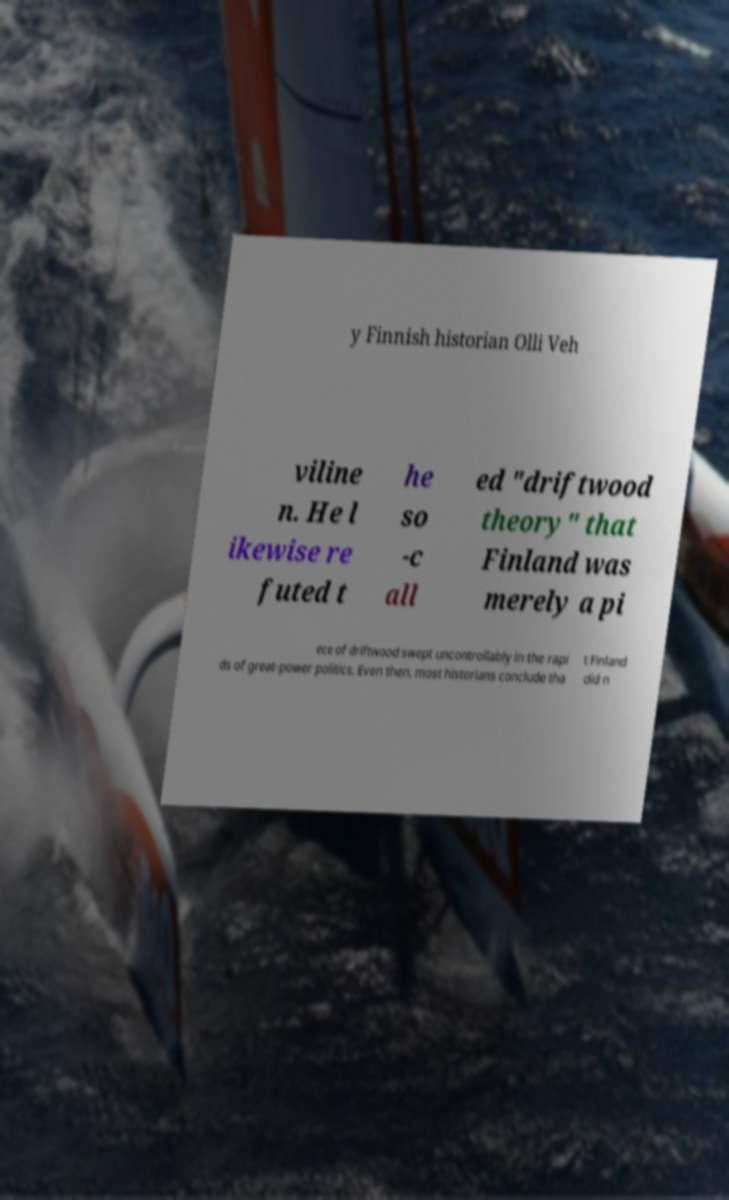Please read and relay the text visible in this image. What does it say? y Finnish historian Olli Veh viline n. He l ikewise re futed t he so -c all ed "driftwood theory" that Finland was merely a pi ece of driftwood swept uncontrollably in the rapi ds of great-power politics. Even then, most historians conclude tha t Finland did n 